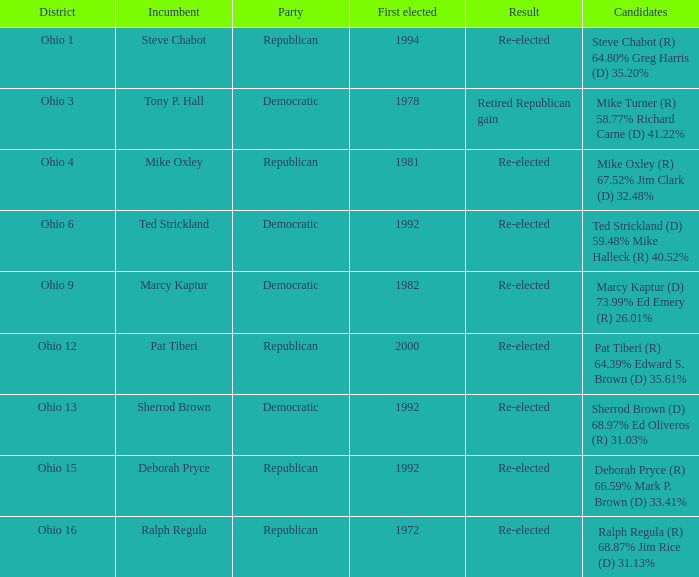Incumbent Deborah Pryce was a member of what party?  Republican. 